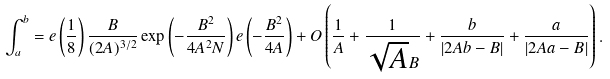<formula> <loc_0><loc_0><loc_500><loc_500>\int _ { a } ^ { b } = e \left ( \frac { 1 } { 8 } \right ) \frac { B } { ( 2 A ) ^ { 3 / 2 } } \exp \left ( - \frac { B ^ { 2 } } { 4 A ^ { 2 } N } \right ) e \left ( - \frac { B ^ { 2 } } { 4 A } \right ) + O \left ( \frac { 1 } { A } + \frac { 1 } { \sqrt { A } B } + \frac { b } { | 2 A b - B | } + \frac { a } { | 2 A a - B | } \right ) .</formula> 